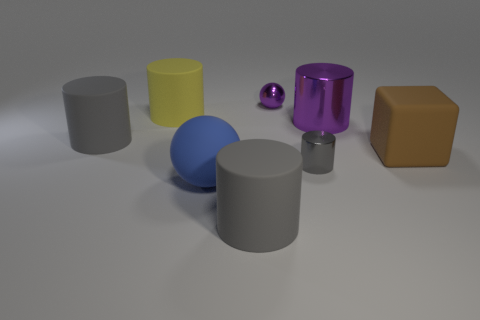Subtract all purple cylinders. How many cylinders are left? 4 Subtract all large gray cylinders. How many cylinders are left? 3 Subtract all blocks. How many objects are left? 7 Subtract 4 cylinders. How many cylinders are left? 1 Add 1 yellow rubber cylinders. How many objects exist? 9 Subtract all blue cylinders. How many gray spheres are left? 0 Add 6 purple balls. How many purple balls are left? 7 Add 6 yellow cylinders. How many yellow cylinders exist? 7 Subtract 0 brown balls. How many objects are left? 8 Subtract all green cylinders. Subtract all gray balls. How many cylinders are left? 5 